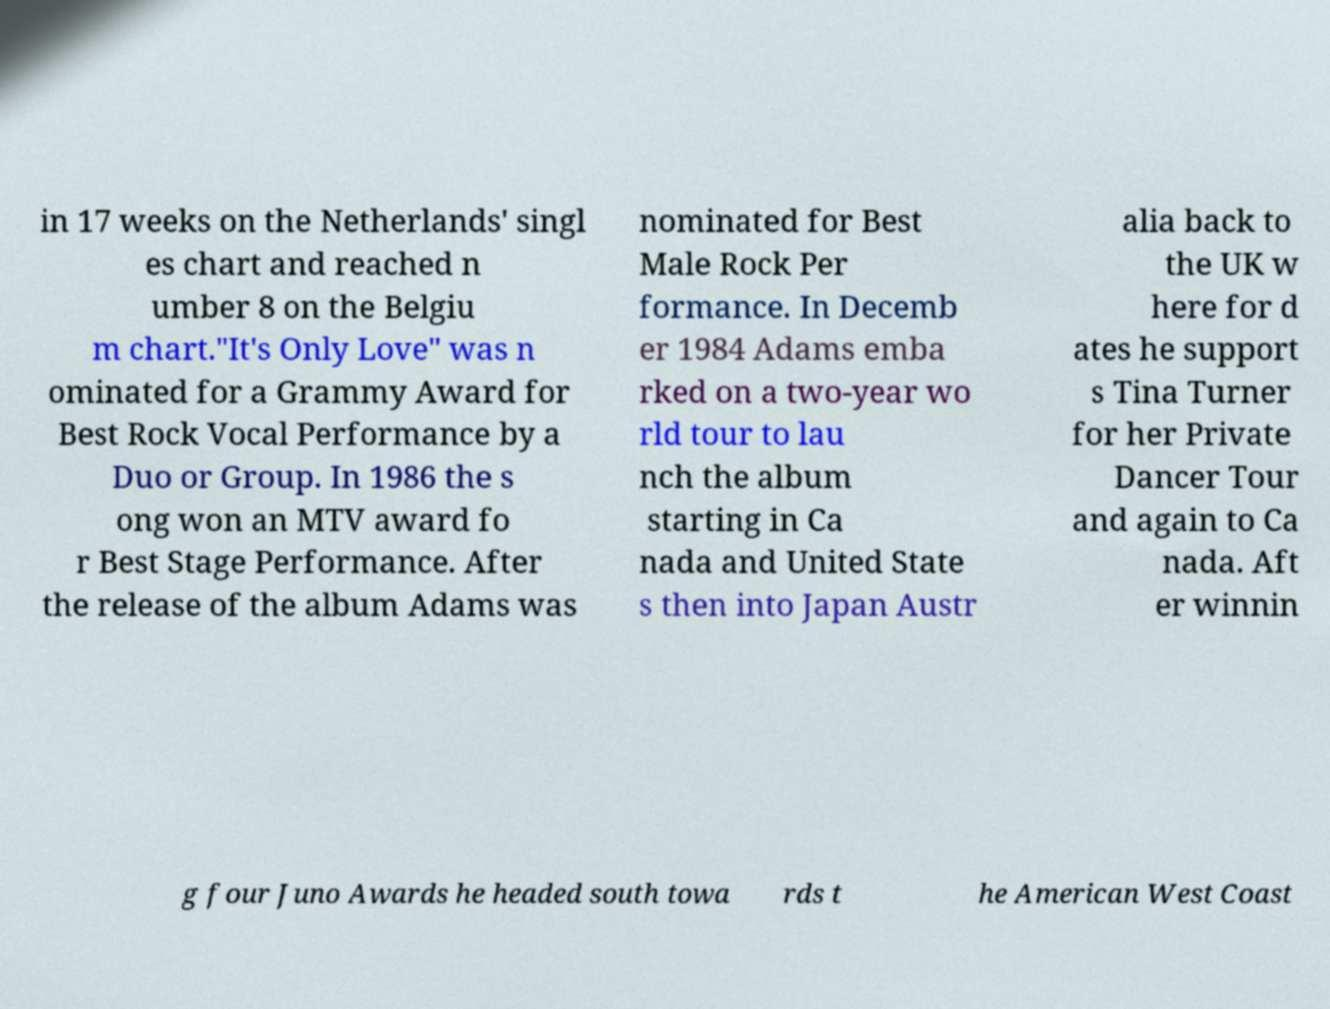Please read and relay the text visible in this image. What does it say? in 17 weeks on the Netherlands' singl es chart and reached n umber 8 on the Belgiu m chart."It's Only Love" was n ominated for a Grammy Award for Best Rock Vocal Performance by a Duo or Group. In 1986 the s ong won an MTV award fo r Best Stage Performance. After the release of the album Adams was nominated for Best Male Rock Per formance. In Decemb er 1984 Adams emba rked on a two-year wo rld tour to lau nch the album starting in Ca nada and United State s then into Japan Austr alia back to the UK w here for d ates he support s Tina Turner for her Private Dancer Tour and again to Ca nada. Aft er winnin g four Juno Awards he headed south towa rds t he American West Coast 